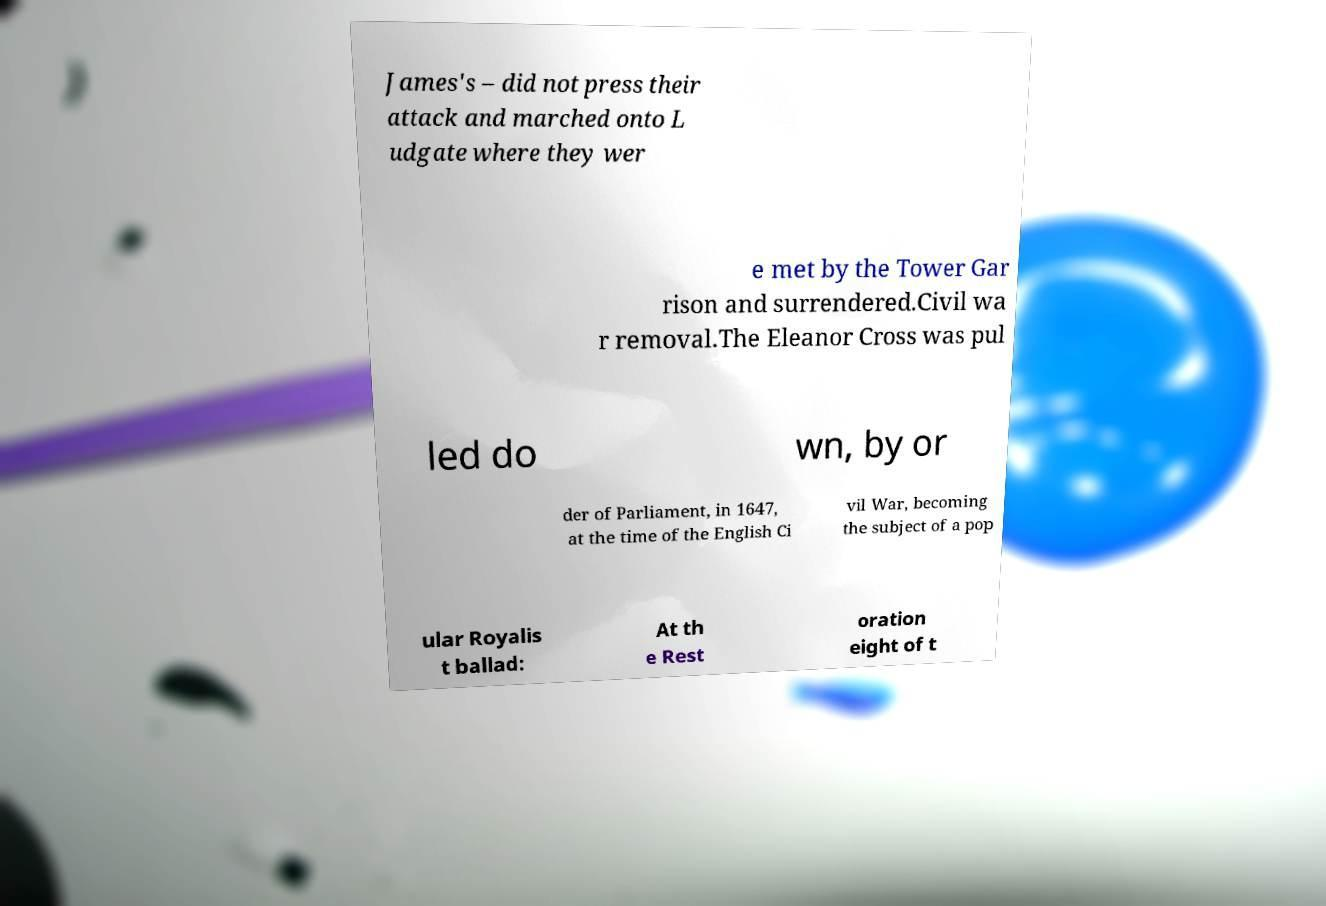Please read and relay the text visible in this image. What does it say? James's – did not press their attack and marched onto L udgate where they wer e met by the Tower Gar rison and surrendered.Civil wa r removal.The Eleanor Cross was pul led do wn, by or der of Parliament, in 1647, at the time of the English Ci vil War, becoming the subject of a pop ular Royalis t ballad: At th e Rest oration eight of t 